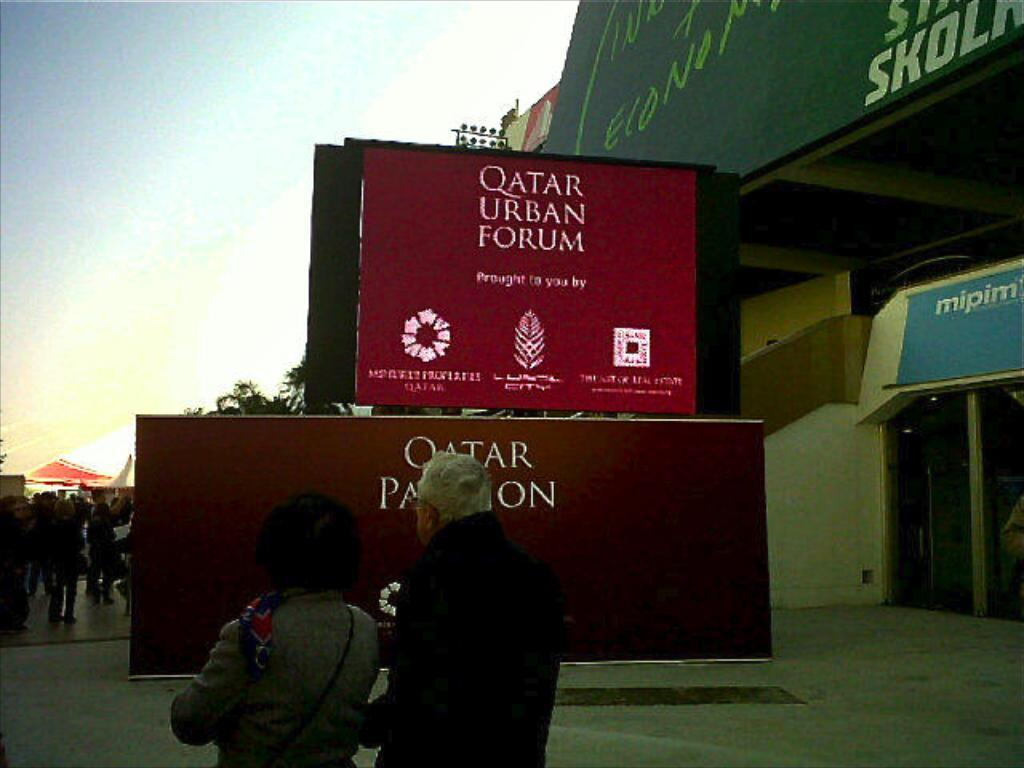How many persons are visible in the image? There are two persons standing in the image. What can be seen in the background of the image? In the background of the image, there are hoardings, name boards, buildings, trees, lights on poles, and a group of people. What is visible in the sky in the image? The sky is visible in the background of the image. What type of patch is being used to make the soup in the image? There is no patch or soup present in the image. What type of vacation is being planned by the persons in the image? There is no indication of a vacation or any planning in the image. 